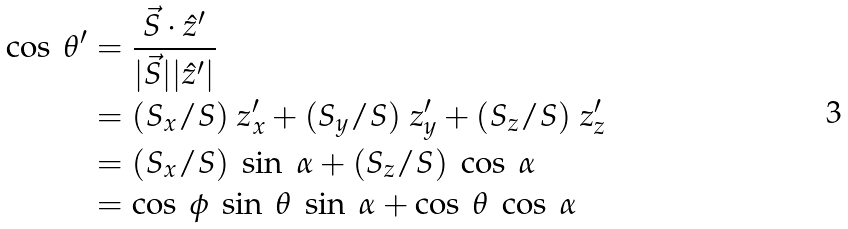Convert formula to latex. <formula><loc_0><loc_0><loc_500><loc_500>\cos \ \theta ^ { \prime } & = \frac { \vec { S } \cdot \hat { z } ^ { \prime } } { | \vec { S } | | \hat { z } ^ { \prime } | } \\ & = ( S _ { x } / S ) \ z ^ { \prime } _ { x } + ( S _ { y } / S ) \ z ^ { \prime } _ { y } + ( S _ { z } / S ) \ z ^ { \prime } _ { z } \\ & = ( S _ { x } / S ) \ \sin \ \alpha + ( S _ { z } / S ) \ \cos \ \alpha \\ & = \cos \ \phi \ \sin \ \theta \ \sin \ \alpha + \cos \ \theta \ \cos \ \alpha</formula> 